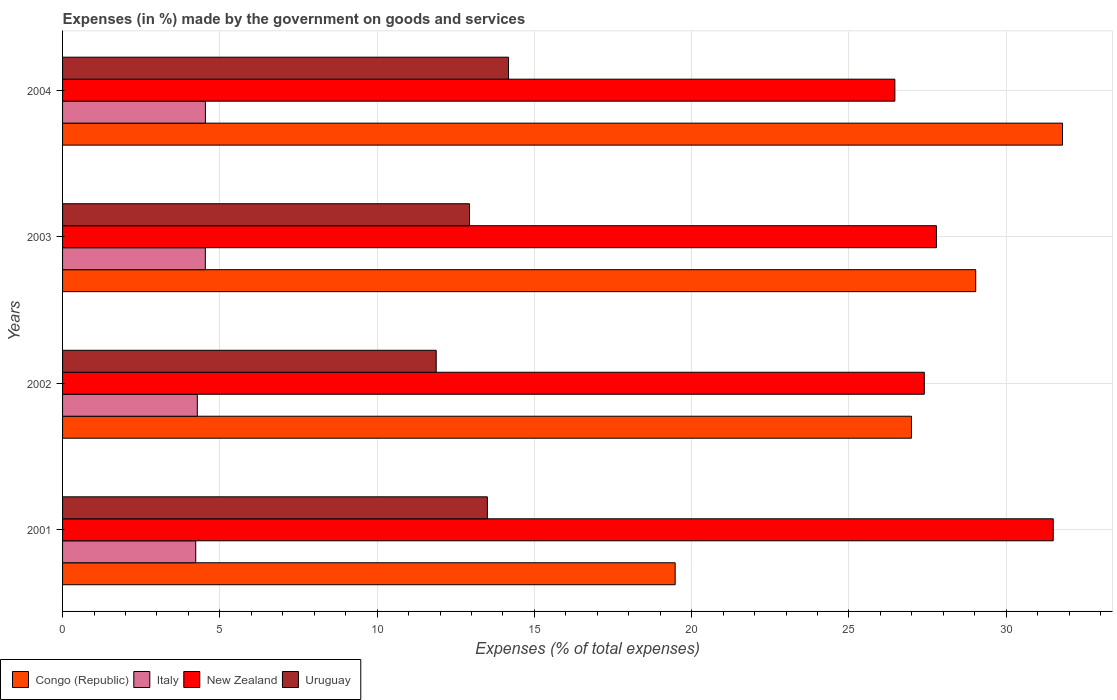How many groups of bars are there?
Offer a very short reply. 4. Are the number of bars on each tick of the Y-axis equal?
Keep it short and to the point. Yes. How many bars are there on the 2nd tick from the top?
Your answer should be compact. 4. What is the label of the 3rd group of bars from the top?
Make the answer very short. 2002. What is the percentage of expenses made by the government on goods and services in Italy in 2001?
Offer a very short reply. 4.23. Across all years, what is the maximum percentage of expenses made by the government on goods and services in Congo (Republic)?
Provide a succinct answer. 31.79. Across all years, what is the minimum percentage of expenses made by the government on goods and services in Italy?
Provide a short and direct response. 4.23. In which year was the percentage of expenses made by the government on goods and services in Uruguay maximum?
Ensure brevity in your answer.  2004. In which year was the percentage of expenses made by the government on goods and services in Uruguay minimum?
Your answer should be compact. 2002. What is the total percentage of expenses made by the government on goods and services in Congo (Republic) in the graph?
Your response must be concise. 107.29. What is the difference between the percentage of expenses made by the government on goods and services in New Zealand in 2001 and that in 2004?
Give a very brief answer. 5.03. What is the difference between the percentage of expenses made by the government on goods and services in Congo (Republic) in 2004 and the percentage of expenses made by the government on goods and services in New Zealand in 2002?
Offer a terse response. 4.39. What is the average percentage of expenses made by the government on goods and services in Uruguay per year?
Your answer should be compact. 13.13. In the year 2002, what is the difference between the percentage of expenses made by the government on goods and services in Uruguay and percentage of expenses made by the government on goods and services in Congo (Republic)?
Your answer should be very brief. -15.11. What is the ratio of the percentage of expenses made by the government on goods and services in Congo (Republic) in 2002 to that in 2003?
Offer a terse response. 0.93. Is the difference between the percentage of expenses made by the government on goods and services in Uruguay in 2001 and 2004 greater than the difference between the percentage of expenses made by the government on goods and services in Congo (Republic) in 2001 and 2004?
Provide a short and direct response. Yes. What is the difference between the highest and the second highest percentage of expenses made by the government on goods and services in New Zealand?
Provide a short and direct response. 3.71. What is the difference between the highest and the lowest percentage of expenses made by the government on goods and services in Congo (Republic)?
Provide a succinct answer. 12.31. In how many years, is the percentage of expenses made by the government on goods and services in Uruguay greater than the average percentage of expenses made by the government on goods and services in Uruguay taken over all years?
Make the answer very short. 2. Is the sum of the percentage of expenses made by the government on goods and services in New Zealand in 2001 and 2004 greater than the maximum percentage of expenses made by the government on goods and services in Italy across all years?
Provide a short and direct response. Yes. Is it the case that in every year, the sum of the percentage of expenses made by the government on goods and services in Uruguay and percentage of expenses made by the government on goods and services in Italy is greater than the sum of percentage of expenses made by the government on goods and services in New Zealand and percentage of expenses made by the government on goods and services in Congo (Republic)?
Provide a succinct answer. No. What does the 2nd bar from the top in 2004 represents?
Ensure brevity in your answer.  New Zealand. What does the 4th bar from the bottom in 2004 represents?
Provide a succinct answer. Uruguay. Is it the case that in every year, the sum of the percentage of expenses made by the government on goods and services in Italy and percentage of expenses made by the government on goods and services in Congo (Republic) is greater than the percentage of expenses made by the government on goods and services in New Zealand?
Ensure brevity in your answer.  No. Are all the bars in the graph horizontal?
Offer a very short reply. Yes. What is the difference between two consecutive major ticks on the X-axis?
Your answer should be very brief. 5. Are the values on the major ticks of X-axis written in scientific E-notation?
Your response must be concise. No. Does the graph contain any zero values?
Your answer should be compact. No. Does the graph contain grids?
Your answer should be compact. Yes. What is the title of the graph?
Provide a succinct answer. Expenses (in %) made by the government on goods and services. What is the label or title of the X-axis?
Provide a succinct answer. Expenses (% of total expenses). What is the Expenses (% of total expenses) of Congo (Republic) in 2001?
Give a very brief answer. 19.48. What is the Expenses (% of total expenses) in Italy in 2001?
Give a very brief answer. 4.23. What is the Expenses (% of total expenses) of New Zealand in 2001?
Your answer should be very brief. 31.5. What is the Expenses (% of total expenses) of Uruguay in 2001?
Give a very brief answer. 13.51. What is the Expenses (% of total expenses) in Congo (Republic) in 2002?
Give a very brief answer. 26.99. What is the Expenses (% of total expenses) of Italy in 2002?
Keep it short and to the point. 4.28. What is the Expenses (% of total expenses) in New Zealand in 2002?
Offer a very short reply. 27.4. What is the Expenses (% of total expenses) of Uruguay in 2002?
Give a very brief answer. 11.88. What is the Expenses (% of total expenses) in Congo (Republic) in 2003?
Make the answer very short. 29.03. What is the Expenses (% of total expenses) in Italy in 2003?
Give a very brief answer. 4.54. What is the Expenses (% of total expenses) in New Zealand in 2003?
Offer a terse response. 27.78. What is the Expenses (% of total expenses) of Uruguay in 2003?
Your response must be concise. 12.94. What is the Expenses (% of total expenses) of Congo (Republic) in 2004?
Provide a succinct answer. 31.79. What is the Expenses (% of total expenses) of Italy in 2004?
Keep it short and to the point. 4.54. What is the Expenses (% of total expenses) in New Zealand in 2004?
Ensure brevity in your answer.  26.46. What is the Expenses (% of total expenses) in Uruguay in 2004?
Your response must be concise. 14.18. Across all years, what is the maximum Expenses (% of total expenses) in Congo (Republic)?
Make the answer very short. 31.79. Across all years, what is the maximum Expenses (% of total expenses) of Italy?
Make the answer very short. 4.54. Across all years, what is the maximum Expenses (% of total expenses) of New Zealand?
Your response must be concise. 31.5. Across all years, what is the maximum Expenses (% of total expenses) in Uruguay?
Your answer should be very brief. 14.18. Across all years, what is the minimum Expenses (% of total expenses) in Congo (Republic)?
Your response must be concise. 19.48. Across all years, what is the minimum Expenses (% of total expenses) in Italy?
Your answer should be very brief. 4.23. Across all years, what is the minimum Expenses (% of total expenses) of New Zealand?
Offer a very short reply. 26.46. Across all years, what is the minimum Expenses (% of total expenses) in Uruguay?
Give a very brief answer. 11.88. What is the total Expenses (% of total expenses) of Congo (Republic) in the graph?
Your response must be concise. 107.29. What is the total Expenses (% of total expenses) in Italy in the graph?
Make the answer very short. 17.6. What is the total Expenses (% of total expenses) of New Zealand in the graph?
Ensure brevity in your answer.  113.14. What is the total Expenses (% of total expenses) in Uruguay in the graph?
Give a very brief answer. 52.5. What is the difference between the Expenses (% of total expenses) of Congo (Republic) in 2001 and that in 2002?
Your answer should be very brief. -7.51. What is the difference between the Expenses (% of total expenses) in Italy in 2001 and that in 2002?
Ensure brevity in your answer.  -0.05. What is the difference between the Expenses (% of total expenses) of New Zealand in 2001 and that in 2002?
Provide a short and direct response. 4.1. What is the difference between the Expenses (% of total expenses) in Uruguay in 2001 and that in 2002?
Ensure brevity in your answer.  1.63. What is the difference between the Expenses (% of total expenses) of Congo (Republic) in 2001 and that in 2003?
Keep it short and to the point. -9.56. What is the difference between the Expenses (% of total expenses) of Italy in 2001 and that in 2003?
Offer a terse response. -0.3. What is the difference between the Expenses (% of total expenses) of New Zealand in 2001 and that in 2003?
Your answer should be very brief. 3.71. What is the difference between the Expenses (% of total expenses) of Uruguay in 2001 and that in 2003?
Keep it short and to the point. 0.57. What is the difference between the Expenses (% of total expenses) of Congo (Republic) in 2001 and that in 2004?
Provide a short and direct response. -12.31. What is the difference between the Expenses (% of total expenses) in Italy in 2001 and that in 2004?
Ensure brevity in your answer.  -0.31. What is the difference between the Expenses (% of total expenses) of New Zealand in 2001 and that in 2004?
Provide a short and direct response. 5.03. What is the difference between the Expenses (% of total expenses) of Uruguay in 2001 and that in 2004?
Your answer should be compact. -0.67. What is the difference between the Expenses (% of total expenses) in Congo (Republic) in 2002 and that in 2003?
Your answer should be very brief. -2.04. What is the difference between the Expenses (% of total expenses) in Italy in 2002 and that in 2003?
Offer a terse response. -0.25. What is the difference between the Expenses (% of total expenses) of New Zealand in 2002 and that in 2003?
Offer a very short reply. -0.39. What is the difference between the Expenses (% of total expenses) of Uruguay in 2002 and that in 2003?
Your answer should be very brief. -1.06. What is the difference between the Expenses (% of total expenses) in Congo (Republic) in 2002 and that in 2004?
Offer a very short reply. -4.8. What is the difference between the Expenses (% of total expenses) of Italy in 2002 and that in 2004?
Offer a terse response. -0.26. What is the difference between the Expenses (% of total expenses) in New Zealand in 2002 and that in 2004?
Your answer should be compact. 0.94. What is the difference between the Expenses (% of total expenses) of Uruguay in 2002 and that in 2004?
Offer a terse response. -2.3. What is the difference between the Expenses (% of total expenses) of Congo (Republic) in 2003 and that in 2004?
Your answer should be very brief. -2.76. What is the difference between the Expenses (% of total expenses) of Italy in 2003 and that in 2004?
Give a very brief answer. -0. What is the difference between the Expenses (% of total expenses) in New Zealand in 2003 and that in 2004?
Provide a succinct answer. 1.32. What is the difference between the Expenses (% of total expenses) in Uruguay in 2003 and that in 2004?
Offer a terse response. -1.24. What is the difference between the Expenses (% of total expenses) in Congo (Republic) in 2001 and the Expenses (% of total expenses) in Italy in 2002?
Give a very brief answer. 15.19. What is the difference between the Expenses (% of total expenses) in Congo (Republic) in 2001 and the Expenses (% of total expenses) in New Zealand in 2002?
Offer a terse response. -7.92. What is the difference between the Expenses (% of total expenses) in Congo (Republic) in 2001 and the Expenses (% of total expenses) in Uruguay in 2002?
Your answer should be very brief. 7.6. What is the difference between the Expenses (% of total expenses) of Italy in 2001 and the Expenses (% of total expenses) of New Zealand in 2002?
Offer a terse response. -23.16. What is the difference between the Expenses (% of total expenses) of Italy in 2001 and the Expenses (% of total expenses) of Uruguay in 2002?
Your answer should be compact. -7.65. What is the difference between the Expenses (% of total expenses) of New Zealand in 2001 and the Expenses (% of total expenses) of Uruguay in 2002?
Your answer should be compact. 19.62. What is the difference between the Expenses (% of total expenses) of Congo (Republic) in 2001 and the Expenses (% of total expenses) of Italy in 2003?
Provide a succinct answer. 14.94. What is the difference between the Expenses (% of total expenses) in Congo (Republic) in 2001 and the Expenses (% of total expenses) in New Zealand in 2003?
Your answer should be compact. -8.31. What is the difference between the Expenses (% of total expenses) of Congo (Republic) in 2001 and the Expenses (% of total expenses) of Uruguay in 2003?
Provide a short and direct response. 6.54. What is the difference between the Expenses (% of total expenses) of Italy in 2001 and the Expenses (% of total expenses) of New Zealand in 2003?
Your response must be concise. -23.55. What is the difference between the Expenses (% of total expenses) of Italy in 2001 and the Expenses (% of total expenses) of Uruguay in 2003?
Provide a short and direct response. -8.7. What is the difference between the Expenses (% of total expenses) of New Zealand in 2001 and the Expenses (% of total expenses) of Uruguay in 2003?
Give a very brief answer. 18.56. What is the difference between the Expenses (% of total expenses) of Congo (Republic) in 2001 and the Expenses (% of total expenses) of Italy in 2004?
Your answer should be compact. 14.94. What is the difference between the Expenses (% of total expenses) in Congo (Republic) in 2001 and the Expenses (% of total expenses) in New Zealand in 2004?
Give a very brief answer. -6.98. What is the difference between the Expenses (% of total expenses) in Congo (Republic) in 2001 and the Expenses (% of total expenses) in Uruguay in 2004?
Your answer should be compact. 5.3. What is the difference between the Expenses (% of total expenses) in Italy in 2001 and the Expenses (% of total expenses) in New Zealand in 2004?
Ensure brevity in your answer.  -22.23. What is the difference between the Expenses (% of total expenses) of Italy in 2001 and the Expenses (% of total expenses) of Uruguay in 2004?
Your response must be concise. -9.94. What is the difference between the Expenses (% of total expenses) in New Zealand in 2001 and the Expenses (% of total expenses) in Uruguay in 2004?
Offer a very short reply. 17.32. What is the difference between the Expenses (% of total expenses) of Congo (Republic) in 2002 and the Expenses (% of total expenses) of Italy in 2003?
Provide a short and direct response. 22.45. What is the difference between the Expenses (% of total expenses) in Congo (Republic) in 2002 and the Expenses (% of total expenses) in New Zealand in 2003?
Make the answer very short. -0.79. What is the difference between the Expenses (% of total expenses) in Congo (Republic) in 2002 and the Expenses (% of total expenses) in Uruguay in 2003?
Ensure brevity in your answer.  14.05. What is the difference between the Expenses (% of total expenses) of Italy in 2002 and the Expenses (% of total expenses) of New Zealand in 2003?
Provide a short and direct response. -23.5. What is the difference between the Expenses (% of total expenses) of Italy in 2002 and the Expenses (% of total expenses) of Uruguay in 2003?
Provide a short and direct response. -8.65. What is the difference between the Expenses (% of total expenses) of New Zealand in 2002 and the Expenses (% of total expenses) of Uruguay in 2003?
Give a very brief answer. 14.46. What is the difference between the Expenses (% of total expenses) of Congo (Republic) in 2002 and the Expenses (% of total expenses) of Italy in 2004?
Offer a very short reply. 22.45. What is the difference between the Expenses (% of total expenses) in Congo (Republic) in 2002 and the Expenses (% of total expenses) in New Zealand in 2004?
Keep it short and to the point. 0.53. What is the difference between the Expenses (% of total expenses) of Congo (Republic) in 2002 and the Expenses (% of total expenses) of Uruguay in 2004?
Your answer should be very brief. 12.81. What is the difference between the Expenses (% of total expenses) of Italy in 2002 and the Expenses (% of total expenses) of New Zealand in 2004?
Offer a very short reply. -22.18. What is the difference between the Expenses (% of total expenses) of Italy in 2002 and the Expenses (% of total expenses) of Uruguay in 2004?
Offer a very short reply. -9.89. What is the difference between the Expenses (% of total expenses) in New Zealand in 2002 and the Expenses (% of total expenses) in Uruguay in 2004?
Make the answer very short. 13.22. What is the difference between the Expenses (% of total expenses) in Congo (Republic) in 2003 and the Expenses (% of total expenses) in Italy in 2004?
Keep it short and to the point. 24.49. What is the difference between the Expenses (% of total expenses) of Congo (Republic) in 2003 and the Expenses (% of total expenses) of New Zealand in 2004?
Make the answer very short. 2.57. What is the difference between the Expenses (% of total expenses) of Congo (Republic) in 2003 and the Expenses (% of total expenses) of Uruguay in 2004?
Your answer should be very brief. 14.85. What is the difference between the Expenses (% of total expenses) of Italy in 2003 and the Expenses (% of total expenses) of New Zealand in 2004?
Keep it short and to the point. -21.92. What is the difference between the Expenses (% of total expenses) of Italy in 2003 and the Expenses (% of total expenses) of Uruguay in 2004?
Provide a short and direct response. -9.64. What is the difference between the Expenses (% of total expenses) of New Zealand in 2003 and the Expenses (% of total expenses) of Uruguay in 2004?
Give a very brief answer. 13.6. What is the average Expenses (% of total expenses) of Congo (Republic) per year?
Your answer should be very brief. 26.82. What is the average Expenses (% of total expenses) in Italy per year?
Offer a very short reply. 4.4. What is the average Expenses (% of total expenses) in New Zealand per year?
Provide a succinct answer. 28.28. What is the average Expenses (% of total expenses) in Uruguay per year?
Your answer should be very brief. 13.13. In the year 2001, what is the difference between the Expenses (% of total expenses) in Congo (Republic) and Expenses (% of total expenses) in Italy?
Ensure brevity in your answer.  15.24. In the year 2001, what is the difference between the Expenses (% of total expenses) of Congo (Republic) and Expenses (% of total expenses) of New Zealand?
Offer a very short reply. -12.02. In the year 2001, what is the difference between the Expenses (% of total expenses) in Congo (Republic) and Expenses (% of total expenses) in Uruguay?
Offer a terse response. 5.97. In the year 2001, what is the difference between the Expenses (% of total expenses) of Italy and Expenses (% of total expenses) of New Zealand?
Provide a short and direct response. -27.26. In the year 2001, what is the difference between the Expenses (% of total expenses) in Italy and Expenses (% of total expenses) in Uruguay?
Ensure brevity in your answer.  -9.27. In the year 2001, what is the difference between the Expenses (% of total expenses) in New Zealand and Expenses (% of total expenses) in Uruguay?
Offer a very short reply. 17.99. In the year 2002, what is the difference between the Expenses (% of total expenses) in Congo (Republic) and Expenses (% of total expenses) in Italy?
Offer a terse response. 22.7. In the year 2002, what is the difference between the Expenses (% of total expenses) of Congo (Republic) and Expenses (% of total expenses) of New Zealand?
Give a very brief answer. -0.41. In the year 2002, what is the difference between the Expenses (% of total expenses) of Congo (Republic) and Expenses (% of total expenses) of Uruguay?
Your answer should be compact. 15.11. In the year 2002, what is the difference between the Expenses (% of total expenses) of Italy and Expenses (% of total expenses) of New Zealand?
Give a very brief answer. -23.11. In the year 2002, what is the difference between the Expenses (% of total expenses) in Italy and Expenses (% of total expenses) in Uruguay?
Offer a terse response. -7.6. In the year 2002, what is the difference between the Expenses (% of total expenses) in New Zealand and Expenses (% of total expenses) in Uruguay?
Make the answer very short. 15.52. In the year 2003, what is the difference between the Expenses (% of total expenses) of Congo (Republic) and Expenses (% of total expenses) of Italy?
Provide a succinct answer. 24.49. In the year 2003, what is the difference between the Expenses (% of total expenses) in Congo (Republic) and Expenses (% of total expenses) in New Zealand?
Ensure brevity in your answer.  1.25. In the year 2003, what is the difference between the Expenses (% of total expenses) in Congo (Republic) and Expenses (% of total expenses) in Uruguay?
Your response must be concise. 16.09. In the year 2003, what is the difference between the Expenses (% of total expenses) in Italy and Expenses (% of total expenses) in New Zealand?
Your answer should be compact. -23.24. In the year 2003, what is the difference between the Expenses (% of total expenses) in Italy and Expenses (% of total expenses) in Uruguay?
Your answer should be very brief. -8.4. In the year 2003, what is the difference between the Expenses (% of total expenses) in New Zealand and Expenses (% of total expenses) in Uruguay?
Your response must be concise. 14.85. In the year 2004, what is the difference between the Expenses (% of total expenses) of Congo (Republic) and Expenses (% of total expenses) of Italy?
Provide a short and direct response. 27.25. In the year 2004, what is the difference between the Expenses (% of total expenses) in Congo (Republic) and Expenses (% of total expenses) in New Zealand?
Give a very brief answer. 5.33. In the year 2004, what is the difference between the Expenses (% of total expenses) of Congo (Republic) and Expenses (% of total expenses) of Uruguay?
Offer a very short reply. 17.61. In the year 2004, what is the difference between the Expenses (% of total expenses) in Italy and Expenses (% of total expenses) in New Zealand?
Your answer should be very brief. -21.92. In the year 2004, what is the difference between the Expenses (% of total expenses) in Italy and Expenses (% of total expenses) in Uruguay?
Provide a succinct answer. -9.64. In the year 2004, what is the difference between the Expenses (% of total expenses) of New Zealand and Expenses (% of total expenses) of Uruguay?
Your answer should be very brief. 12.28. What is the ratio of the Expenses (% of total expenses) in Congo (Republic) in 2001 to that in 2002?
Provide a succinct answer. 0.72. What is the ratio of the Expenses (% of total expenses) of Italy in 2001 to that in 2002?
Offer a very short reply. 0.99. What is the ratio of the Expenses (% of total expenses) in New Zealand in 2001 to that in 2002?
Make the answer very short. 1.15. What is the ratio of the Expenses (% of total expenses) in Uruguay in 2001 to that in 2002?
Your response must be concise. 1.14. What is the ratio of the Expenses (% of total expenses) in Congo (Republic) in 2001 to that in 2003?
Your answer should be very brief. 0.67. What is the ratio of the Expenses (% of total expenses) in Italy in 2001 to that in 2003?
Give a very brief answer. 0.93. What is the ratio of the Expenses (% of total expenses) in New Zealand in 2001 to that in 2003?
Ensure brevity in your answer.  1.13. What is the ratio of the Expenses (% of total expenses) of Uruguay in 2001 to that in 2003?
Give a very brief answer. 1.04. What is the ratio of the Expenses (% of total expenses) of Congo (Republic) in 2001 to that in 2004?
Offer a terse response. 0.61. What is the ratio of the Expenses (% of total expenses) in Italy in 2001 to that in 2004?
Provide a succinct answer. 0.93. What is the ratio of the Expenses (% of total expenses) in New Zealand in 2001 to that in 2004?
Your response must be concise. 1.19. What is the ratio of the Expenses (% of total expenses) of Uruguay in 2001 to that in 2004?
Offer a terse response. 0.95. What is the ratio of the Expenses (% of total expenses) of Congo (Republic) in 2002 to that in 2003?
Ensure brevity in your answer.  0.93. What is the ratio of the Expenses (% of total expenses) of Italy in 2002 to that in 2003?
Keep it short and to the point. 0.94. What is the ratio of the Expenses (% of total expenses) of New Zealand in 2002 to that in 2003?
Give a very brief answer. 0.99. What is the ratio of the Expenses (% of total expenses) of Uruguay in 2002 to that in 2003?
Offer a very short reply. 0.92. What is the ratio of the Expenses (% of total expenses) in Congo (Republic) in 2002 to that in 2004?
Your response must be concise. 0.85. What is the ratio of the Expenses (% of total expenses) of Italy in 2002 to that in 2004?
Provide a short and direct response. 0.94. What is the ratio of the Expenses (% of total expenses) in New Zealand in 2002 to that in 2004?
Provide a short and direct response. 1.04. What is the ratio of the Expenses (% of total expenses) in Uruguay in 2002 to that in 2004?
Ensure brevity in your answer.  0.84. What is the ratio of the Expenses (% of total expenses) in Congo (Republic) in 2003 to that in 2004?
Give a very brief answer. 0.91. What is the ratio of the Expenses (% of total expenses) of Italy in 2003 to that in 2004?
Ensure brevity in your answer.  1. What is the ratio of the Expenses (% of total expenses) in New Zealand in 2003 to that in 2004?
Your response must be concise. 1.05. What is the ratio of the Expenses (% of total expenses) of Uruguay in 2003 to that in 2004?
Keep it short and to the point. 0.91. What is the difference between the highest and the second highest Expenses (% of total expenses) of Congo (Republic)?
Provide a succinct answer. 2.76. What is the difference between the highest and the second highest Expenses (% of total expenses) in Italy?
Your answer should be compact. 0. What is the difference between the highest and the second highest Expenses (% of total expenses) of New Zealand?
Ensure brevity in your answer.  3.71. What is the difference between the highest and the second highest Expenses (% of total expenses) in Uruguay?
Your response must be concise. 0.67. What is the difference between the highest and the lowest Expenses (% of total expenses) of Congo (Republic)?
Provide a short and direct response. 12.31. What is the difference between the highest and the lowest Expenses (% of total expenses) in Italy?
Your answer should be very brief. 0.31. What is the difference between the highest and the lowest Expenses (% of total expenses) of New Zealand?
Give a very brief answer. 5.03. What is the difference between the highest and the lowest Expenses (% of total expenses) of Uruguay?
Offer a terse response. 2.3. 